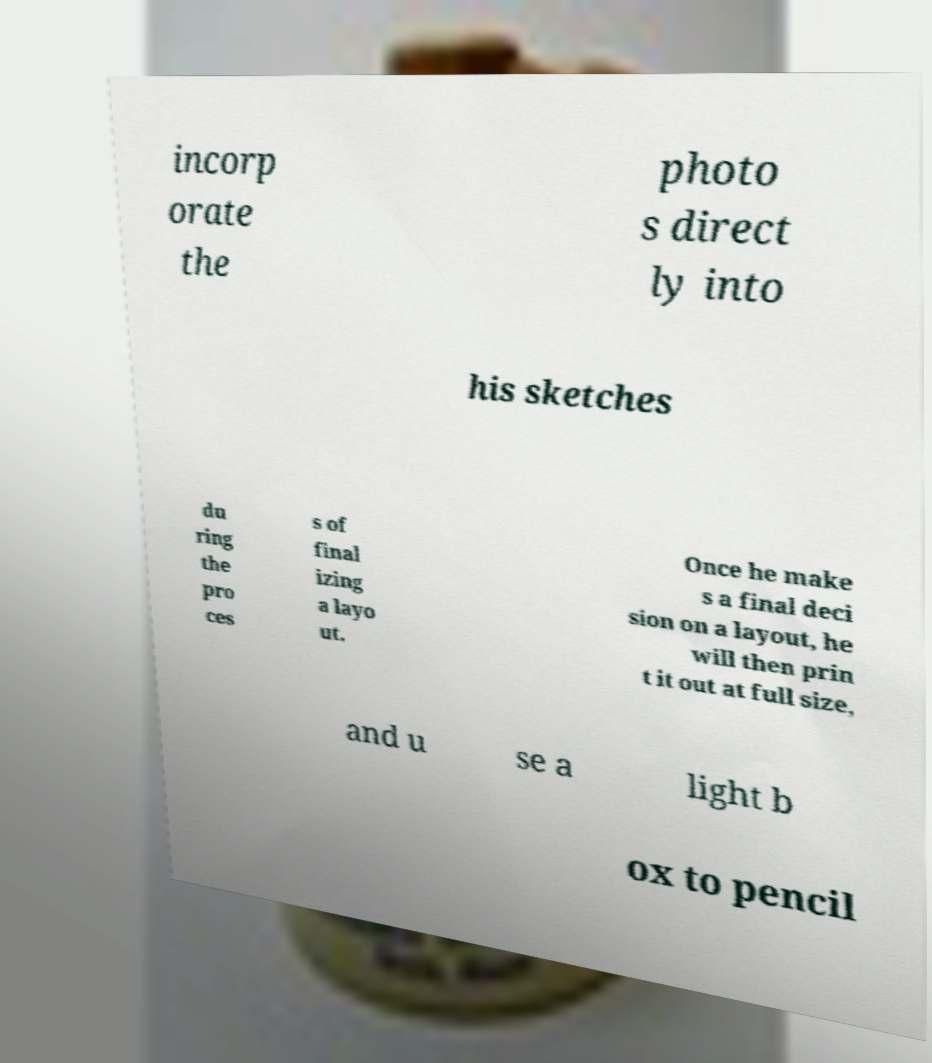Can you accurately transcribe the text from the provided image for me? incorp orate the photo s direct ly into his sketches du ring the pro ces s of final izing a layo ut. Once he make s a final deci sion on a layout, he will then prin t it out at full size, and u se a light b ox to pencil 